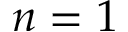Convert formula to latex. <formula><loc_0><loc_0><loc_500><loc_500>n = 1</formula> 